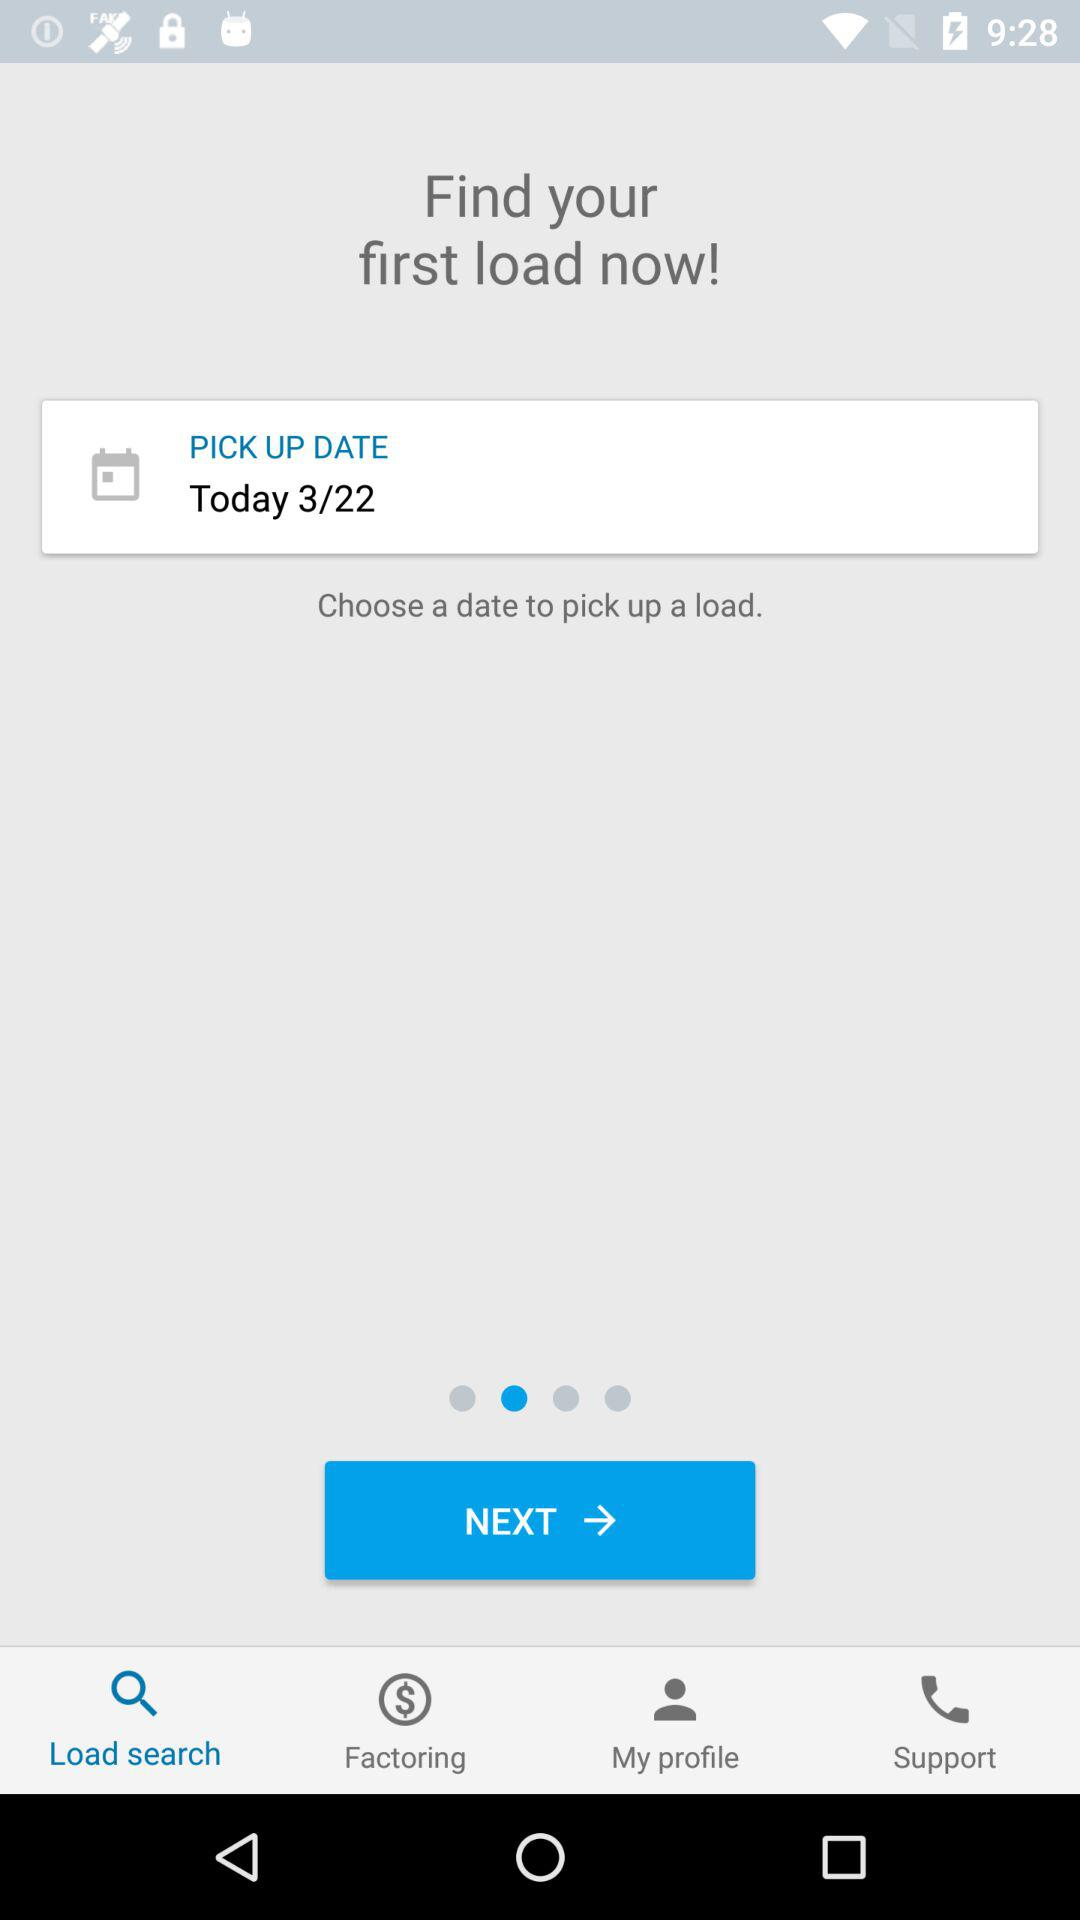Which tab is selected? The selected tab is "Load search". 